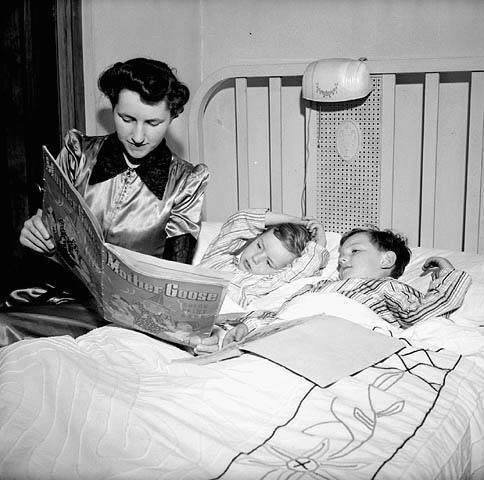How many people are there?
Give a very brief answer. 3. How many books are visible?
Give a very brief answer. 2. How many black sheep are there?
Give a very brief answer. 0. 